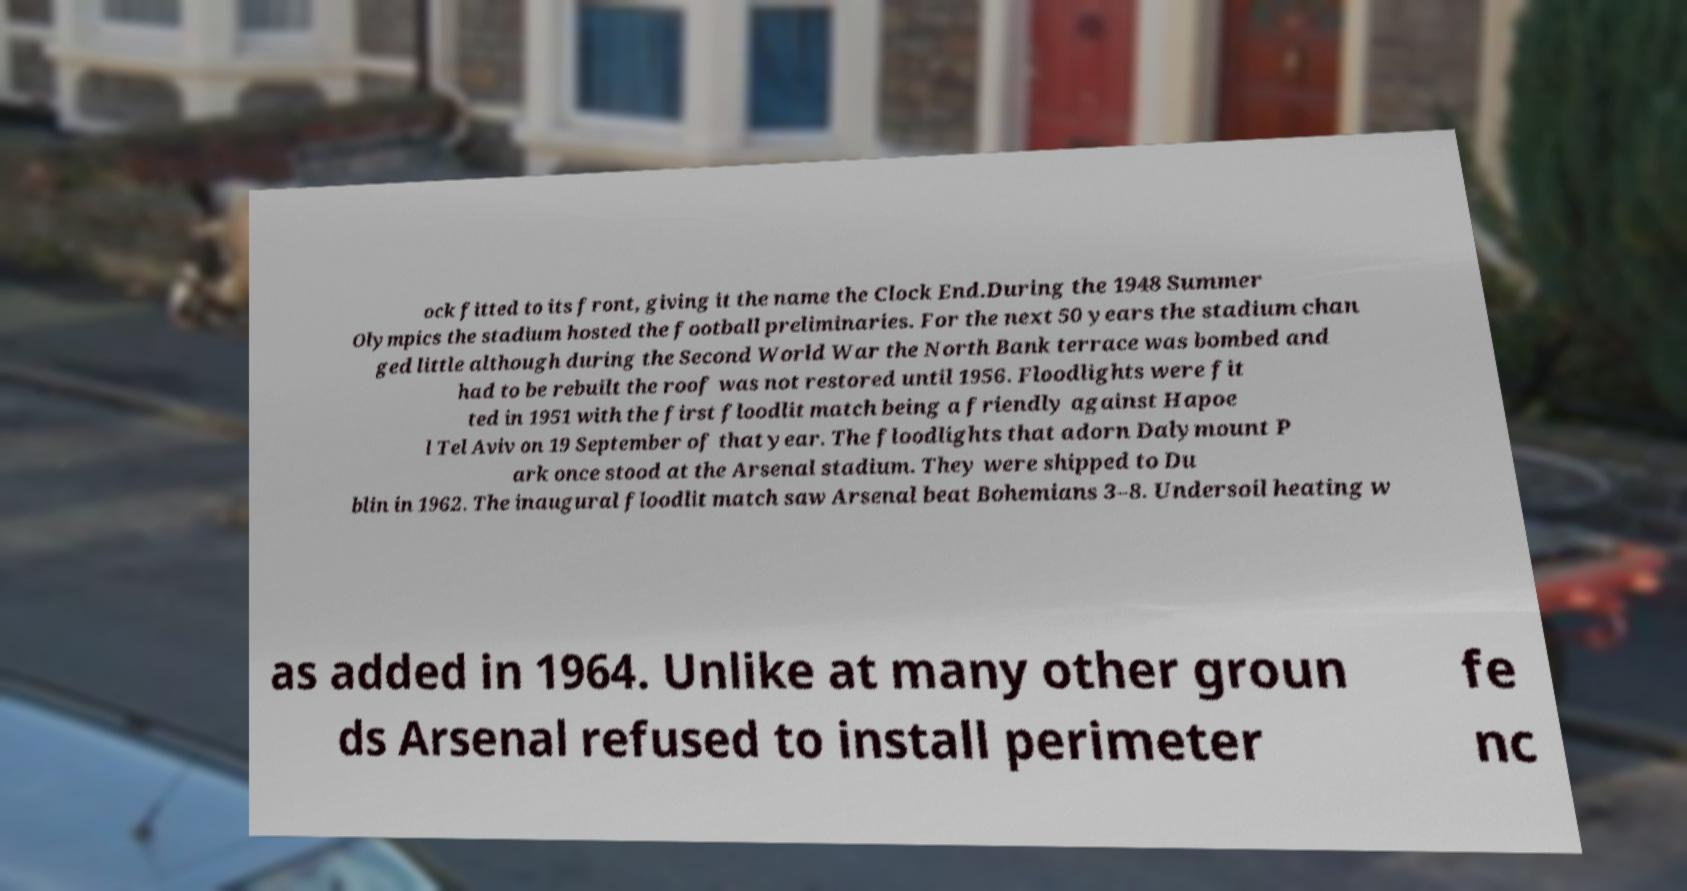Could you extract and type out the text from this image? ock fitted to its front, giving it the name the Clock End.During the 1948 Summer Olympics the stadium hosted the football preliminaries. For the next 50 years the stadium chan ged little although during the Second World War the North Bank terrace was bombed and had to be rebuilt the roof was not restored until 1956. Floodlights were fit ted in 1951 with the first floodlit match being a friendly against Hapoe l Tel Aviv on 19 September of that year. The floodlights that adorn Dalymount P ark once stood at the Arsenal stadium. They were shipped to Du blin in 1962. The inaugural floodlit match saw Arsenal beat Bohemians 3–8. Undersoil heating w as added in 1964. Unlike at many other groun ds Arsenal refused to install perimeter fe nc 